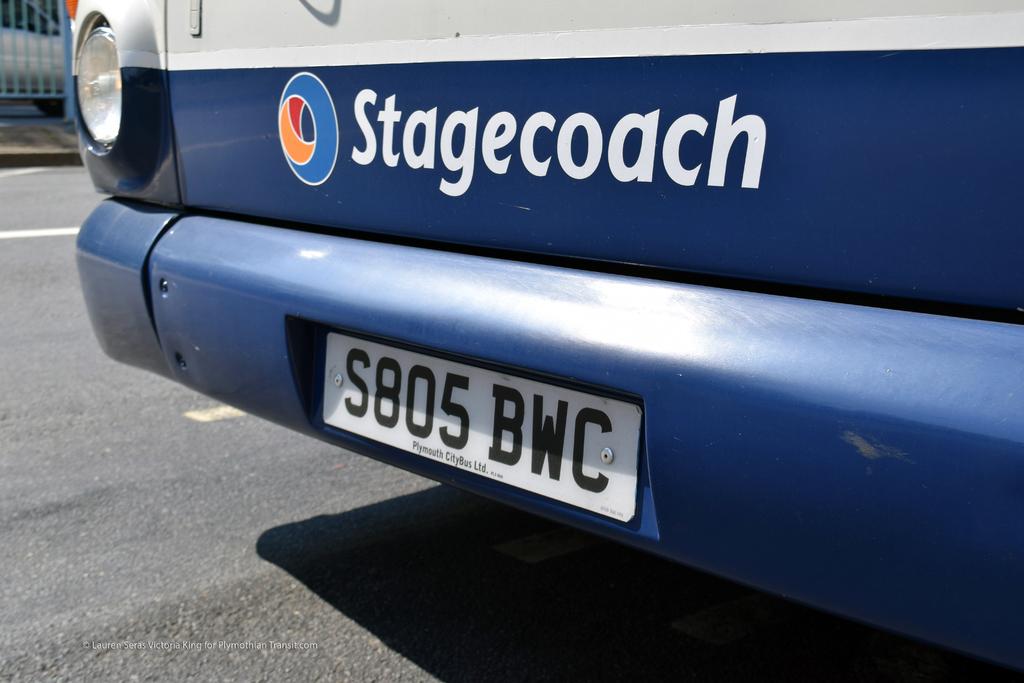What does the bus say it is?
Provide a short and direct response. Stagecoach. 